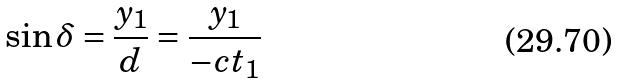Convert formula to latex. <formula><loc_0><loc_0><loc_500><loc_500>\sin \delta = \frac { y _ { 1 } } { d } = \frac { y _ { 1 } } { - c t _ { 1 } }</formula> 